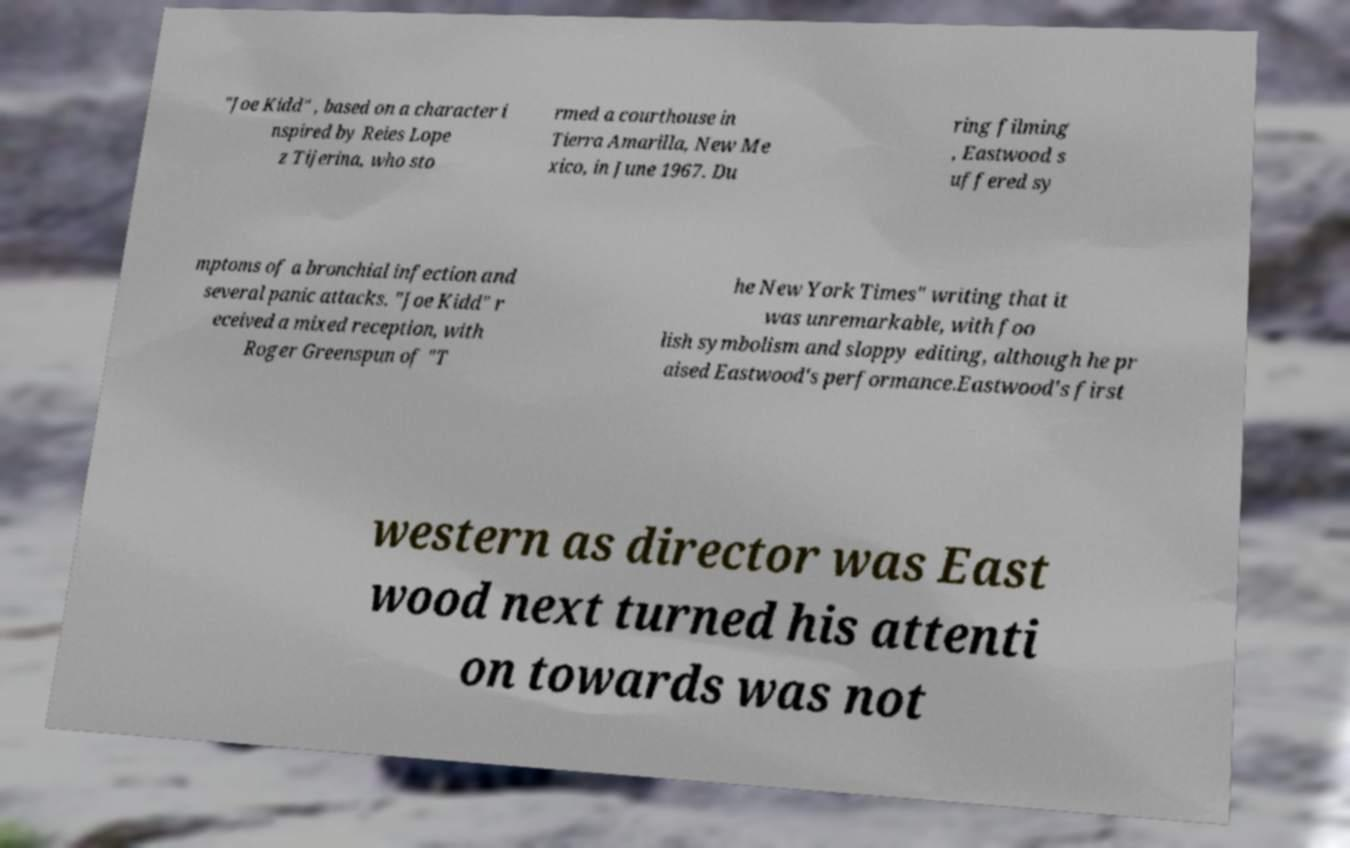For documentation purposes, I need the text within this image transcribed. Could you provide that? "Joe Kidd" , based on a character i nspired by Reies Lope z Tijerina, who sto rmed a courthouse in Tierra Amarilla, New Me xico, in June 1967. Du ring filming , Eastwood s uffered sy mptoms of a bronchial infection and several panic attacks. "Joe Kidd" r eceived a mixed reception, with Roger Greenspun of "T he New York Times" writing that it was unremarkable, with foo lish symbolism and sloppy editing, although he pr aised Eastwood's performance.Eastwood's first western as director was East wood next turned his attenti on towards was not 